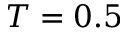Convert formula to latex. <formula><loc_0><loc_0><loc_500><loc_500>T = 0 . 5</formula> 